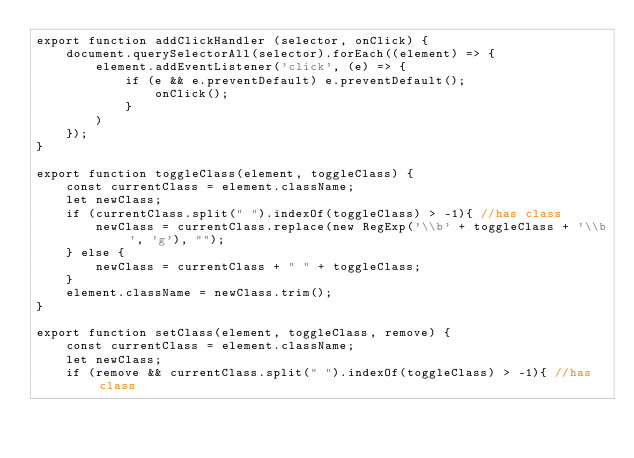<code> <loc_0><loc_0><loc_500><loc_500><_TypeScript_>export function addClickHandler (selector, onClick) {
	document.querySelectorAll(selector).forEach((element) => {
		element.addEventListener('click', (e) => {
			if (e && e.preventDefault) e.preventDefault();
                onClick();
			}
		)		
	});
}

export function toggleClass(element, toggleClass) {
    const currentClass = element.className;
    let newClass;
    if (currentClass.split(" ").indexOf(toggleClass) > -1){ //has class
        newClass = currentClass.replace(new RegExp('\\b' + toggleClass + '\\b', 'g'), "");
    } else {
        newClass = currentClass + " " + toggleClass;
    }
    element.className = newClass.trim();
}

export function setClass(element, toggleClass, remove) {
    const currentClass = element.className;
    let newClass;
    if (remove && currentClass.split(" ").indexOf(toggleClass) > -1){ //has class</code> 